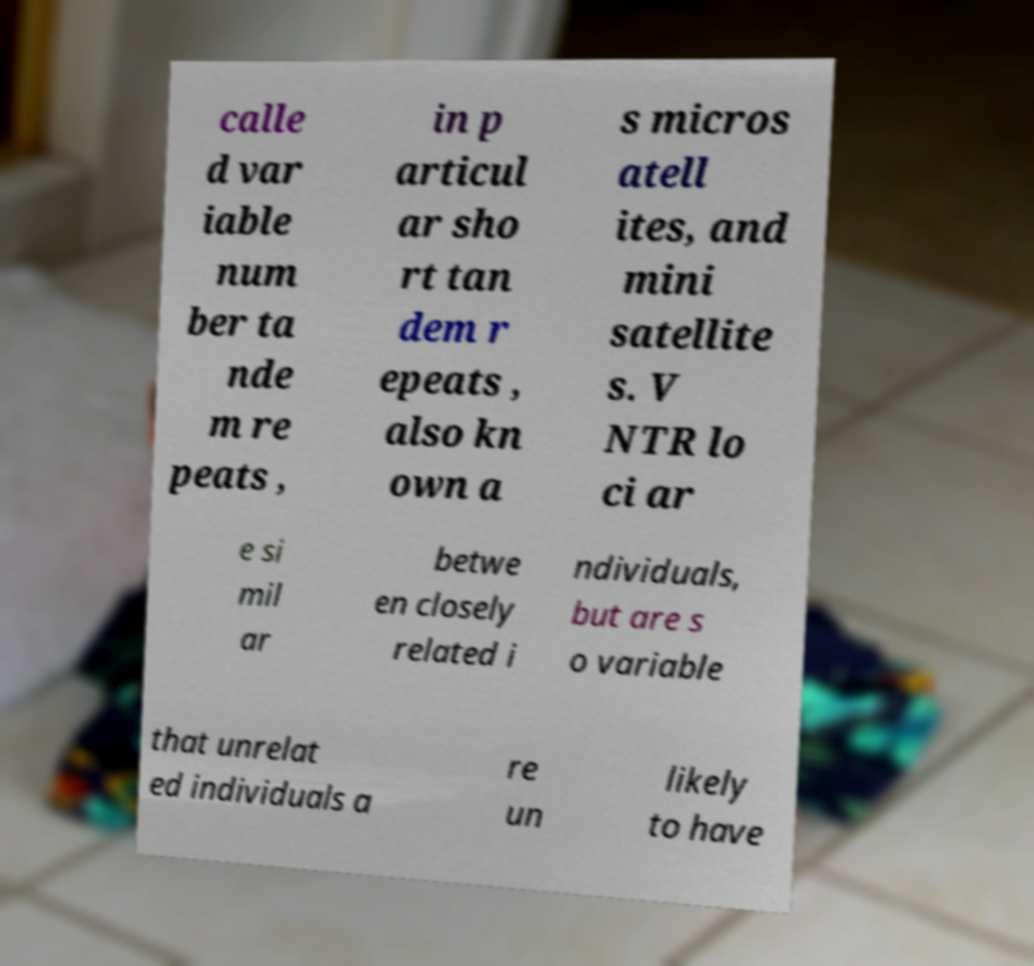What messages or text are displayed in this image? I need them in a readable, typed format. calle d var iable num ber ta nde m re peats , in p articul ar sho rt tan dem r epeats , also kn own a s micros atell ites, and mini satellite s. V NTR lo ci ar e si mil ar betwe en closely related i ndividuals, but are s o variable that unrelat ed individuals a re un likely to have 